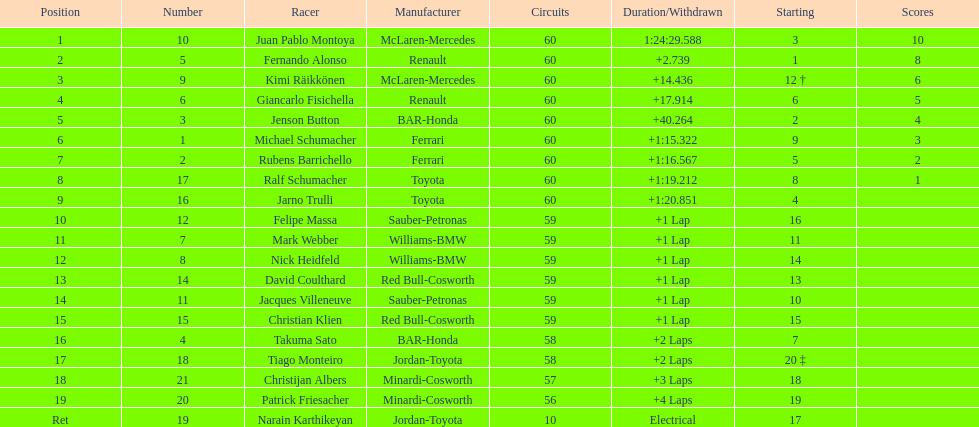Which driver has the least amount of points? Ralf Schumacher. 